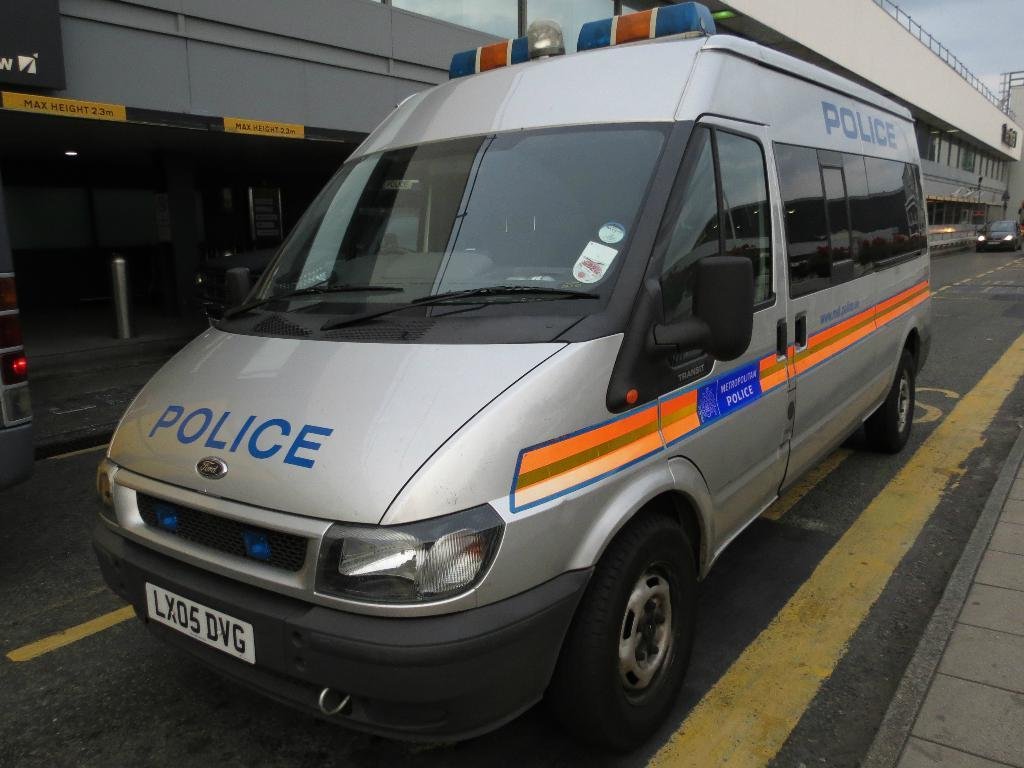<image>
Relay a brief, clear account of the picture shown. A grey Ford van that says Police on the front and the side. 